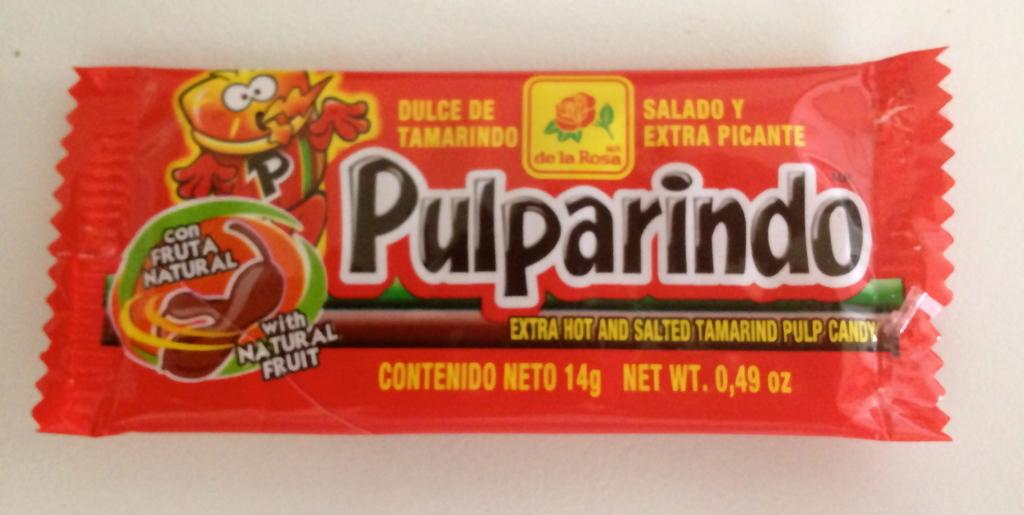<image>
Render a clear and concise summary of the photo. A pulparindo candy wrapper indicates that it is spicy. 